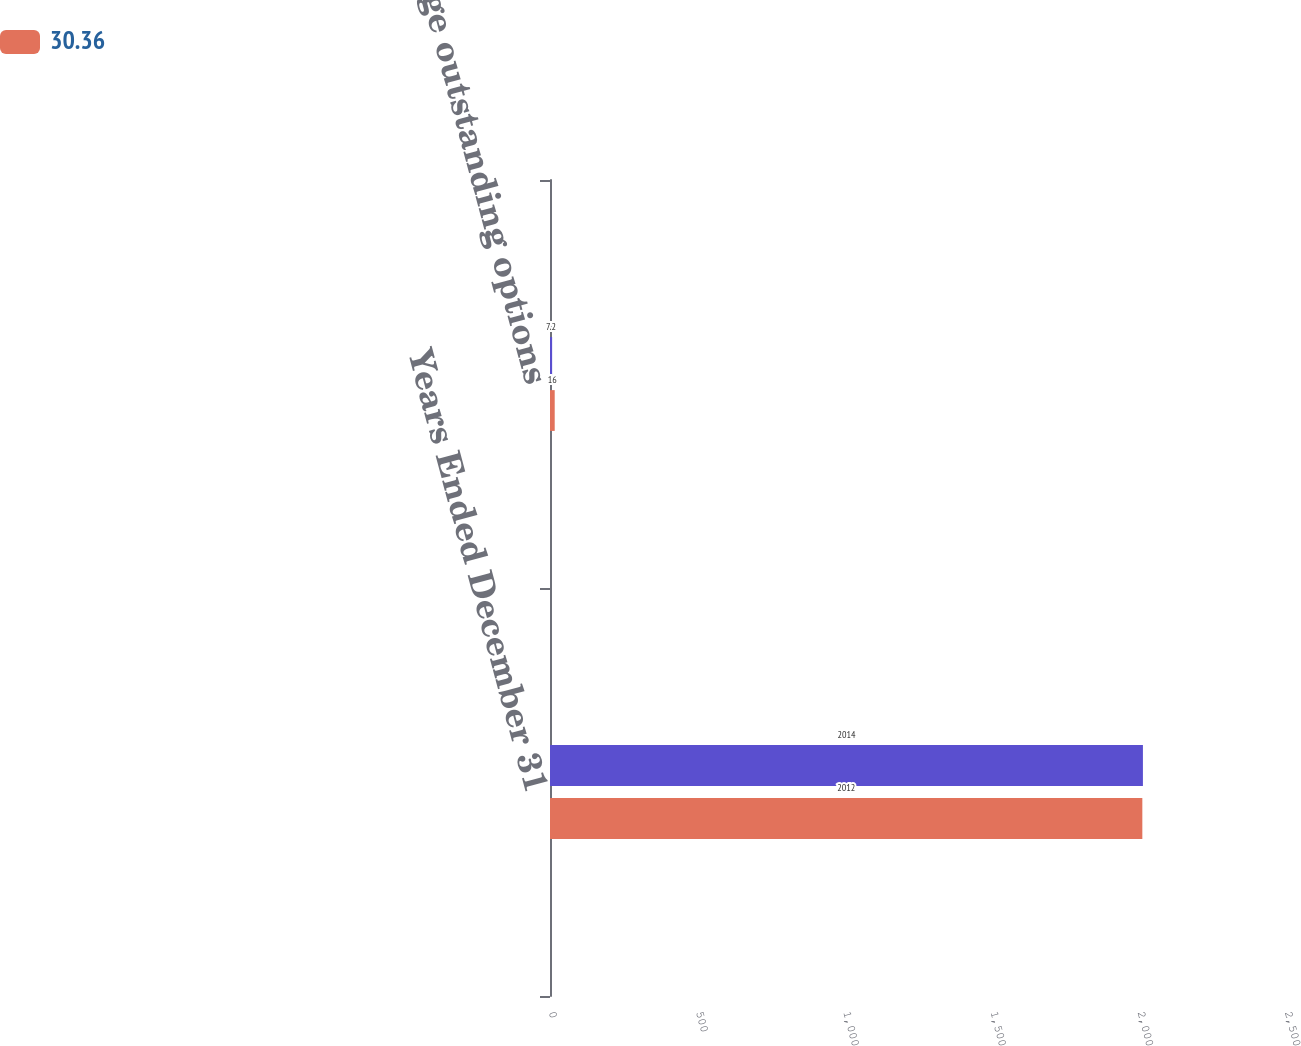<chart> <loc_0><loc_0><loc_500><loc_500><stacked_bar_chart><ecel><fcel>Years Ended December 31<fcel>Average outstanding options<nl><fcel>nan<fcel>2014<fcel>7.2<nl><fcel>30.36<fcel>2012<fcel>16<nl></chart> 